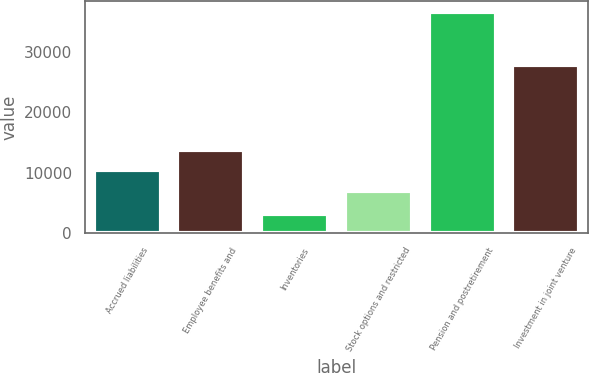Convert chart to OTSL. <chart><loc_0><loc_0><loc_500><loc_500><bar_chart><fcel>Accrued liabilities<fcel>Employee benefits and<fcel>Inventories<fcel>Stock options and restricted<fcel>Pension and postretirement<fcel>Investment in joint venture<nl><fcel>10400.8<fcel>13749.6<fcel>3187<fcel>7052<fcel>36675<fcel>27865<nl></chart> 